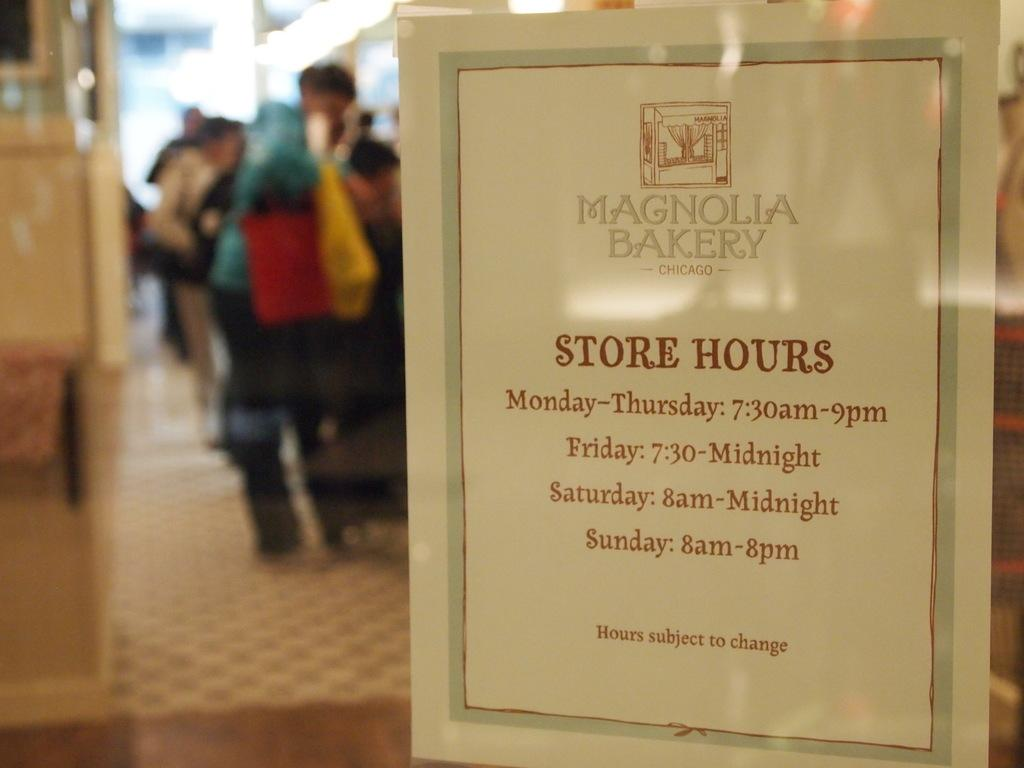<image>
Provide a brief description of the given image. A sign with store hours for the Magnolia Bakery. 